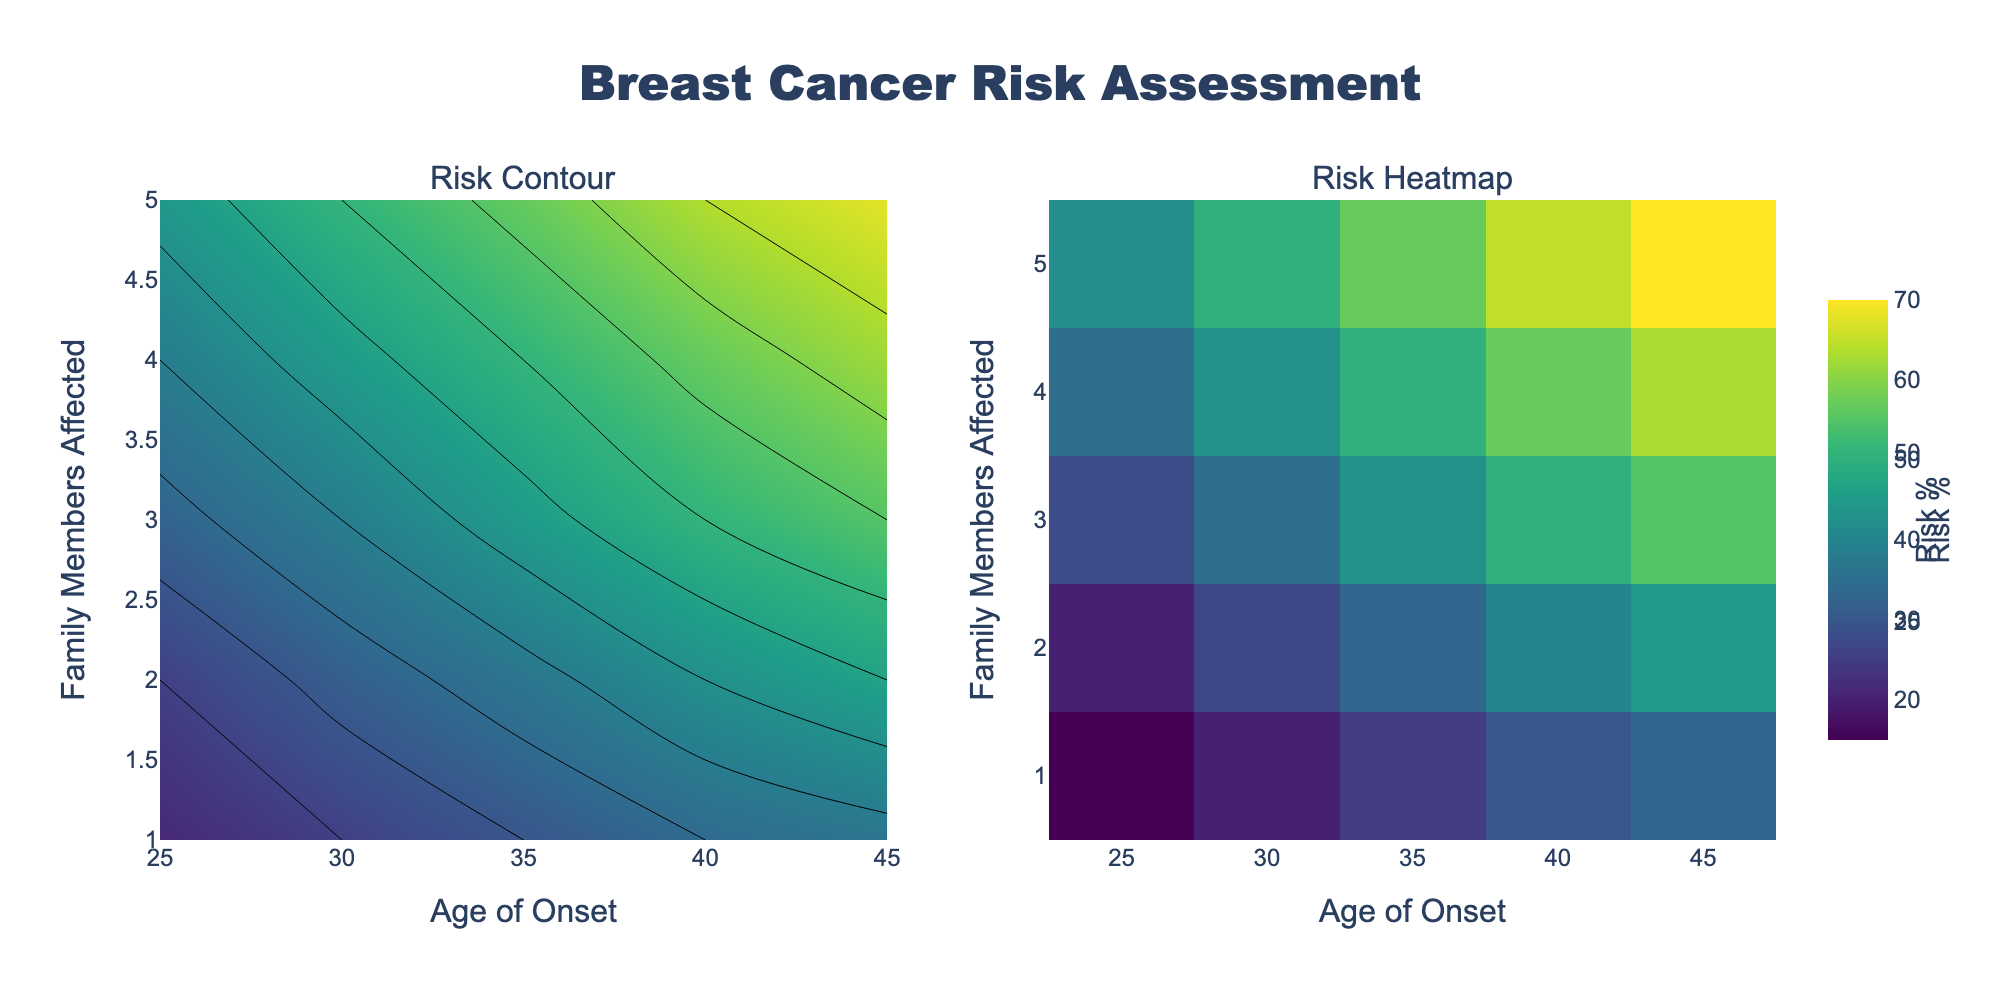What's the title of the figure? The title of a figure is typically placed at the top and is clearly marked in larger font for easy identification. In this figure, the title is "Breast Cancer Risk Assessment".
Answer: Breast Cancer Risk Assessment Which axis represents the number of family members affected? The axis titles are "Age of Onset" and "Family Members Affected". The y-axis is labeled "Family Members Affected", so it represents the number of affected family members.
Answer: Y-axis What color scale is used in the figure? The figure uses the "Viridis" colorscale, which transitions from dark blue to yellow-green for increasing values, providing clear visual cues for risk levels.
Answer: Viridis At what age of onset and number of family members affected does the maximum breast cancer risk occur? To find the maximum risk, look at the points with the highest value on the z-axis. The maximum value occurs at an age of onset of 45 and 5 family members affected, where the risk percentage is 70%.
Answer: Age 45, 5 family members affected How does the risk percentage change with increasing family members affected at age 30? Track the values at age 30 from top to bottom along the column: Risk increases from 20% (1 member) to 27% (2 members), then escalates further with more affected members. This shows the risk percentage rises as the number of affected family members increases.
Answer: Increases What is the risk percentage for someone with 3 family members affected and an age of onset of 40? Look at the contour plot or heatmap and find the intersection of 3 family members affected and age of onset at 40, which shows a risk percentage of 50%.
Answer: 50% Which subplot provides a more detailed view of the risk distribution across family members and age of onset? The "Risk Heatmap" subplot shows a continuous gradation of colors, making it easier to observe subtle changes in risk distribution compared to the contour plot.
Answer: Risk Heatmap What risk percentage range does the color scale cover in the figure? The start and end values of the contour’s color scale are labeled from 10% to 70%, indicating that the observed risk ranges between these percentages.
Answer: 10% to 70% Does the risk percentage always increase with increasing age of onset for the same number of family members affected? By examining the contour lines or specific values horizontally, it is evident that the risk percentage generally increases with age of onset, but the rate and consistency of this increase vary based on the number of family members affected.
Answer: Generally increases 